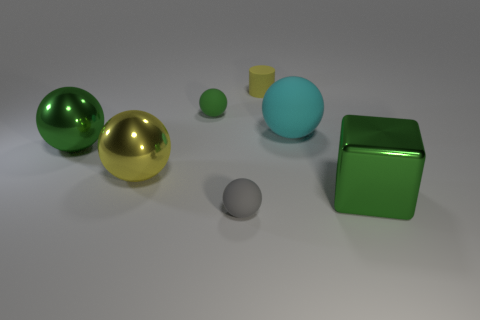There is a large green object that is the same shape as the cyan object; what is it made of?
Ensure brevity in your answer.  Metal. How many big yellow shiny things are there?
Your response must be concise. 1. Are the small cylinder and the big cyan object made of the same material?
Make the answer very short. Yes. What shape is the rubber object that is in front of the shiny object on the right side of the rubber thing that is to the right of the yellow cylinder?
Make the answer very short. Sphere. Do the sphere on the right side of the tiny yellow matte thing and the small ball that is to the right of the tiny green rubber sphere have the same material?
Offer a very short reply. Yes. What material is the yellow cylinder?
Ensure brevity in your answer.  Rubber. How many other green rubber things are the same shape as the tiny green matte object?
Offer a terse response. 0. What is the material of the thing that is the same color as the tiny cylinder?
Keep it short and to the point. Metal. Is there anything else that is the same shape as the green rubber thing?
Ensure brevity in your answer.  Yes. The thing in front of the green object on the right side of the matte thing on the right side of the yellow matte thing is what color?
Your response must be concise. Gray. 